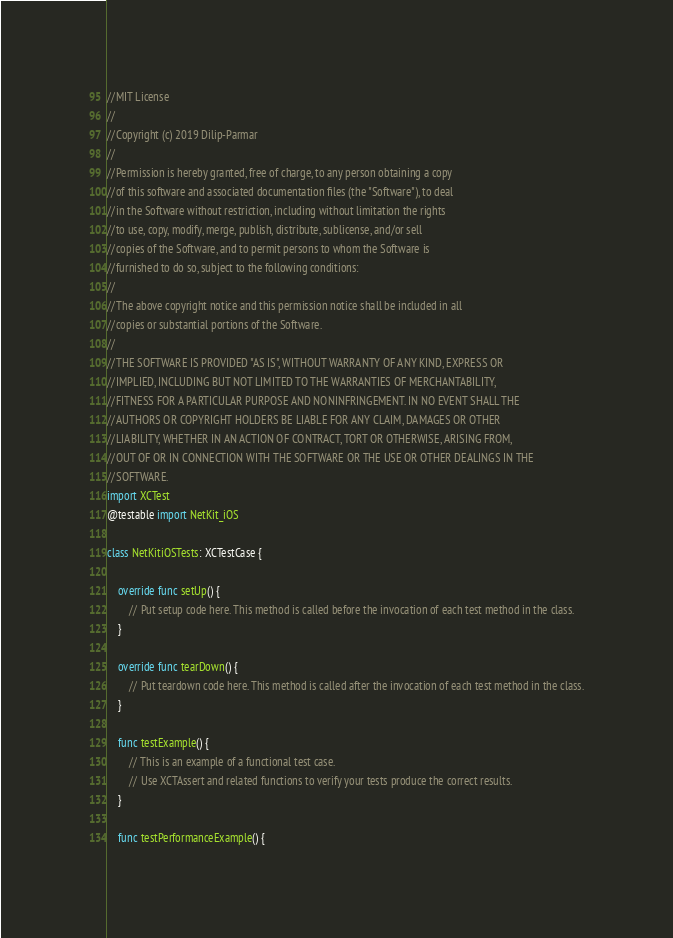Convert code to text. <code><loc_0><loc_0><loc_500><loc_500><_Swift_>//MIT License
//
//Copyright (c) 2019 Dilip-Parmar
//
//Permission is hereby granted, free of charge, to any person obtaining a copy
//of this software and associated documentation files (the "Software"), to deal
//in the Software without restriction, including without limitation the rights
//to use, copy, modify, merge, publish, distribute, sublicense, and/or sell
//copies of the Software, and to permit persons to whom the Software is
//furnished to do so, subject to the following conditions:
//
//The above copyright notice and this permission notice shall be included in all
//copies or substantial portions of the Software.
//
//THE SOFTWARE IS PROVIDED "AS IS", WITHOUT WARRANTY OF ANY KIND, EXPRESS OR
//IMPLIED, INCLUDING BUT NOT LIMITED TO THE WARRANTIES OF MERCHANTABILITY,
//FITNESS FOR A PARTICULAR PURPOSE AND NONINFRINGEMENT. IN NO EVENT SHALL THE
//AUTHORS OR COPYRIGHT HOLDERS BE LIABLE FOR ANY CLAIM, DAMAGES OR OTHER
//LIABILITY, WHETHER IN AN ACTION OF CONTRACT, TORT OR OTHERWISE, ARISING FROM,
//OUT OF OR IN CONNECTION WITH THE SOFTWARE OR THE USE OR OTHER DEALINGS IN THE
//SOFTWARE.
import XCTest
@testable import NetKit_iOS

class NetKitiOSTests: XCTestCase {

    override func setUp() {
        // Put setup code here. This method is called before the invocation of each test method in the class.
    }

    override func tearDown() {
        // Put teardown code here. This method is called after the invocation of each test method in the class.
    }

    func testExample() {
        // This is an example of a functional test case.
        // Use XCTAssert and related functions to verify your tests produce the correct results.
    }

    func testPerformanceExample() {</code> 